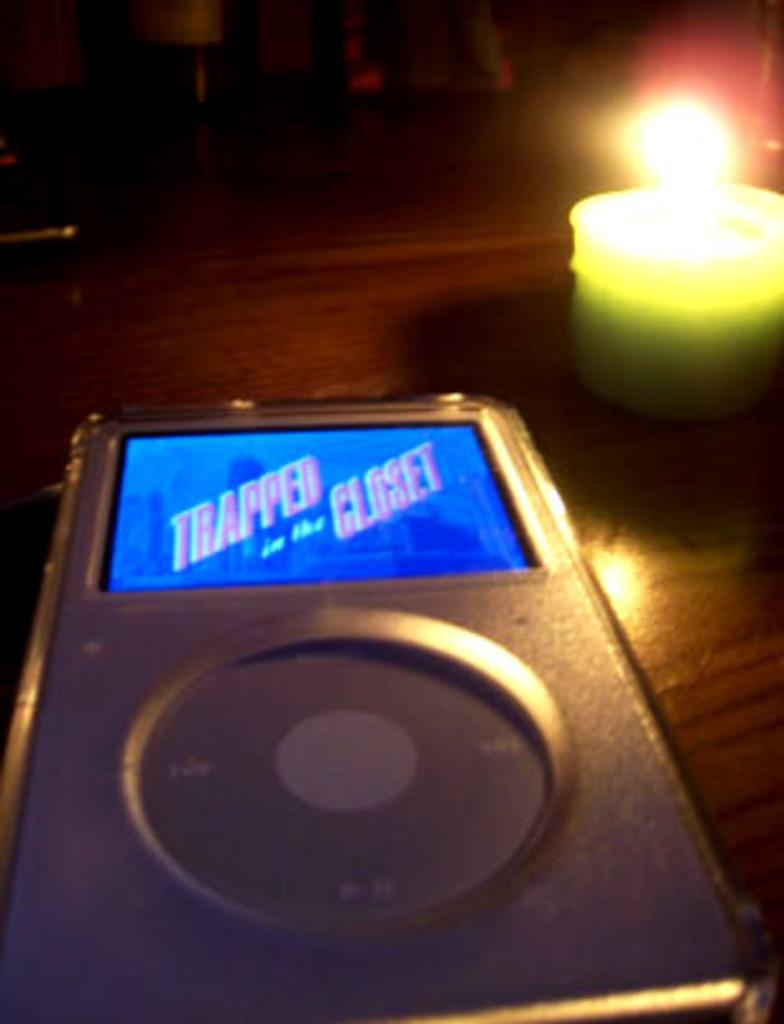What electronic device is visible in the image? There is an Ipod in the image. What is the other object present on the table? There is a candle in the image. Is the candle lit or unlit? The candle is lightened up. Where are the Ipod and the candle located in the image? Both the Ipod and the candle are present on a table. What type of pie is being served in the image? There is no pie present in the image; it features an Ipod and a lit candle on a table. What type of church can be seen in the background of the image? There is no church visible in the image; it only shows an Ipod and a lit candle on a table. 